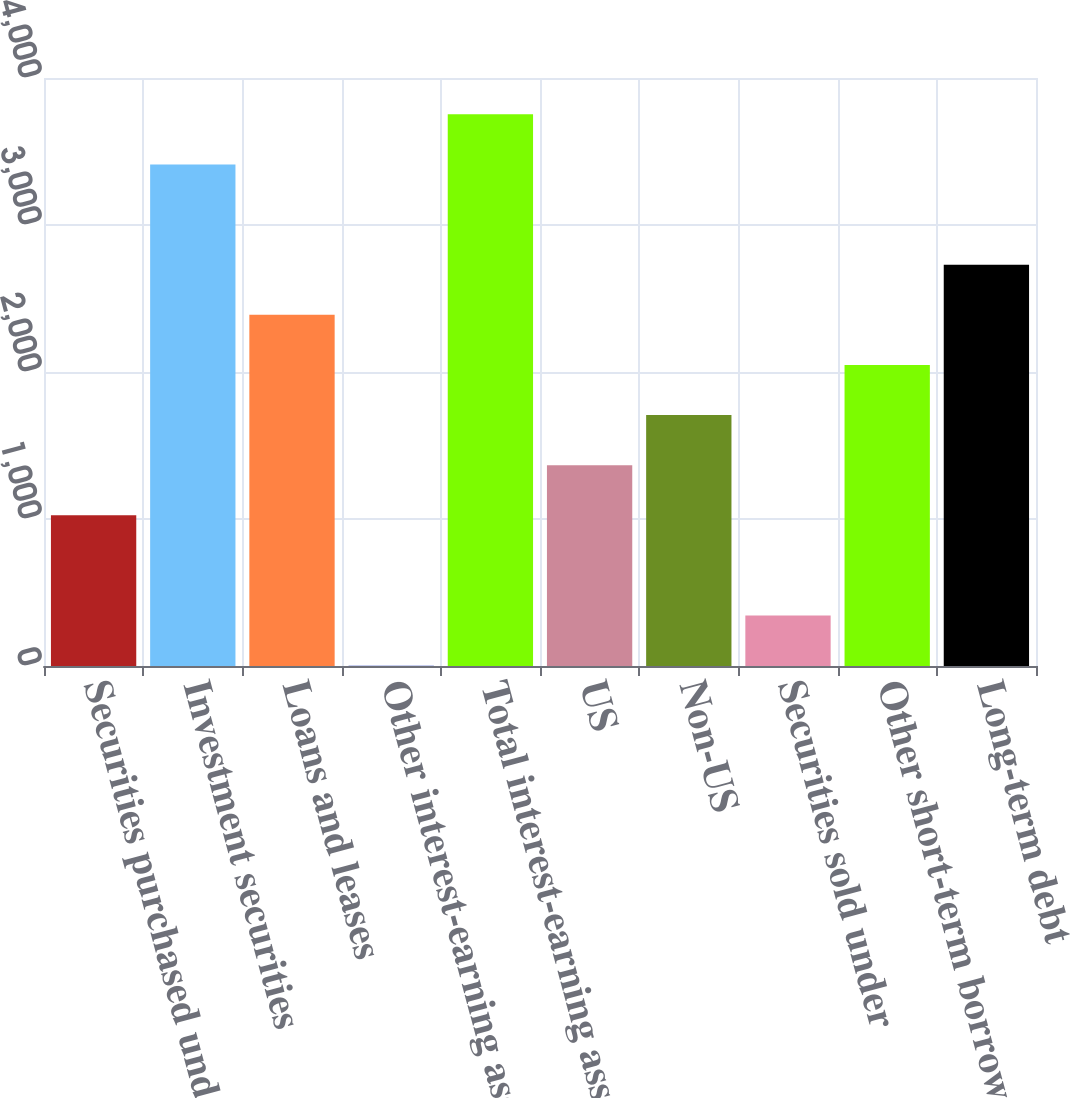Convert chart. <chart><loc_0><loc_0><loc_500><loc_500><bar_chart><fcel>Securities purchased under<fcel>Investment securities<fcel>Loans and leases<fcel>Other interest-earning assets<fcel>Total interest-earning assets<fcel>US<fcel>Non-US<fcel>Securities sold under<fcel>Other short-term borrowings<fcel>Long-term debt<nl><fcel>1025<fcel>3412<fcel>2389<fcel>2<fcel>3753<fcel>1366<fcel>1707<fcel>343<fcel>2048<fcel>2730<nl></chart> 